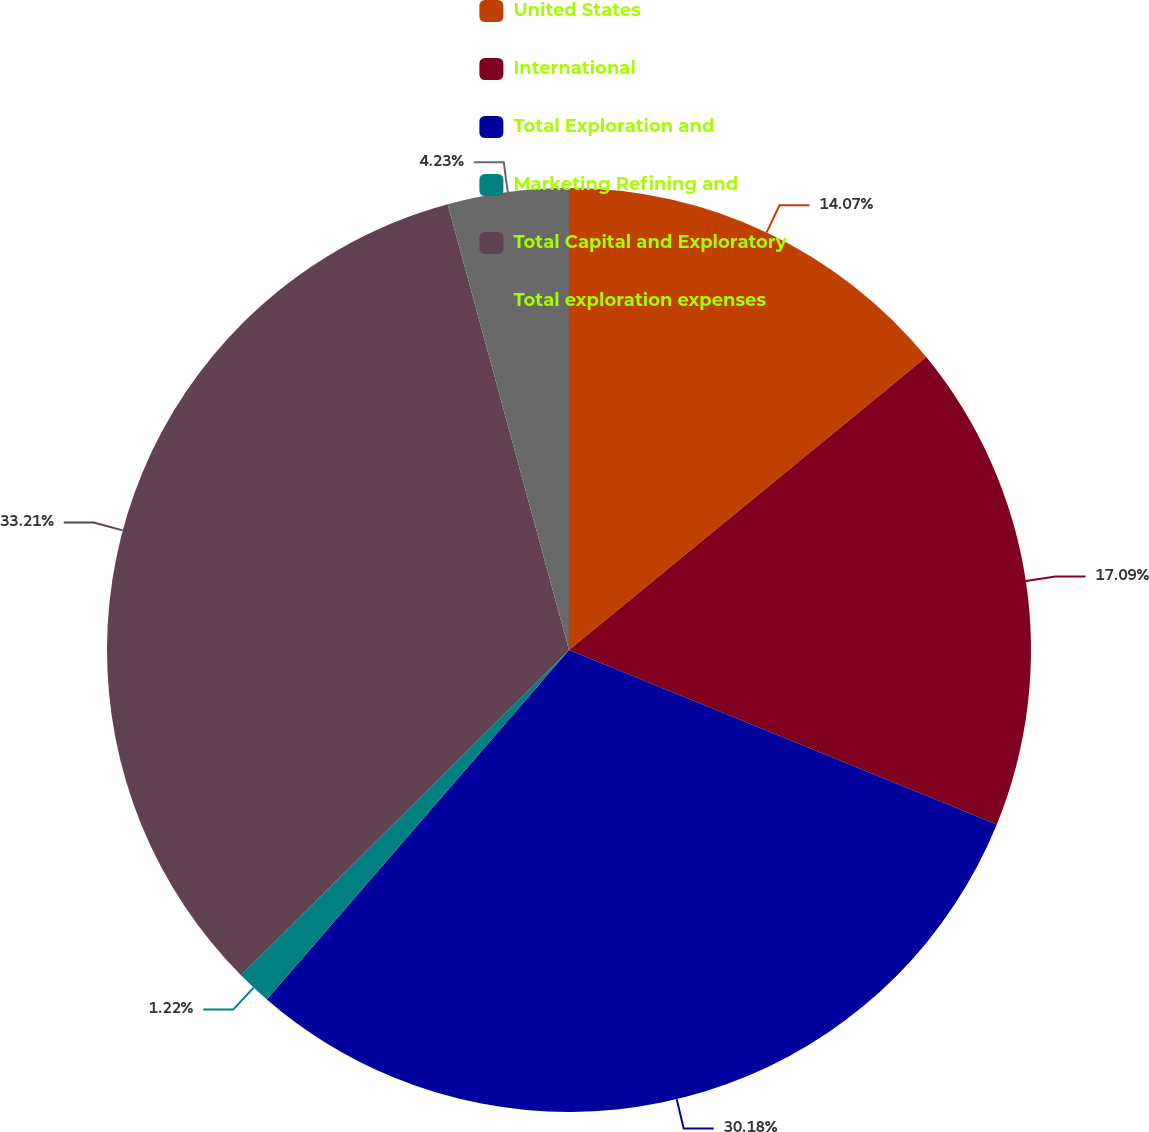Convert chart to OTSL. <chart><loc_0><loc_0><loc_500><loc_500><pie_chart><fcel>United States<fcel>International<fcel>Total Exploration and<fcel>Marketing Refining and<fcel>Total Capital and Exploratory<fcel>Total exploration expenses<nl><fcel>14.07%<fcel>17.09%<fcel>30.18%<fcel>1.22%<fcel>33.2%<fcel>4.23%<nl></chart> 